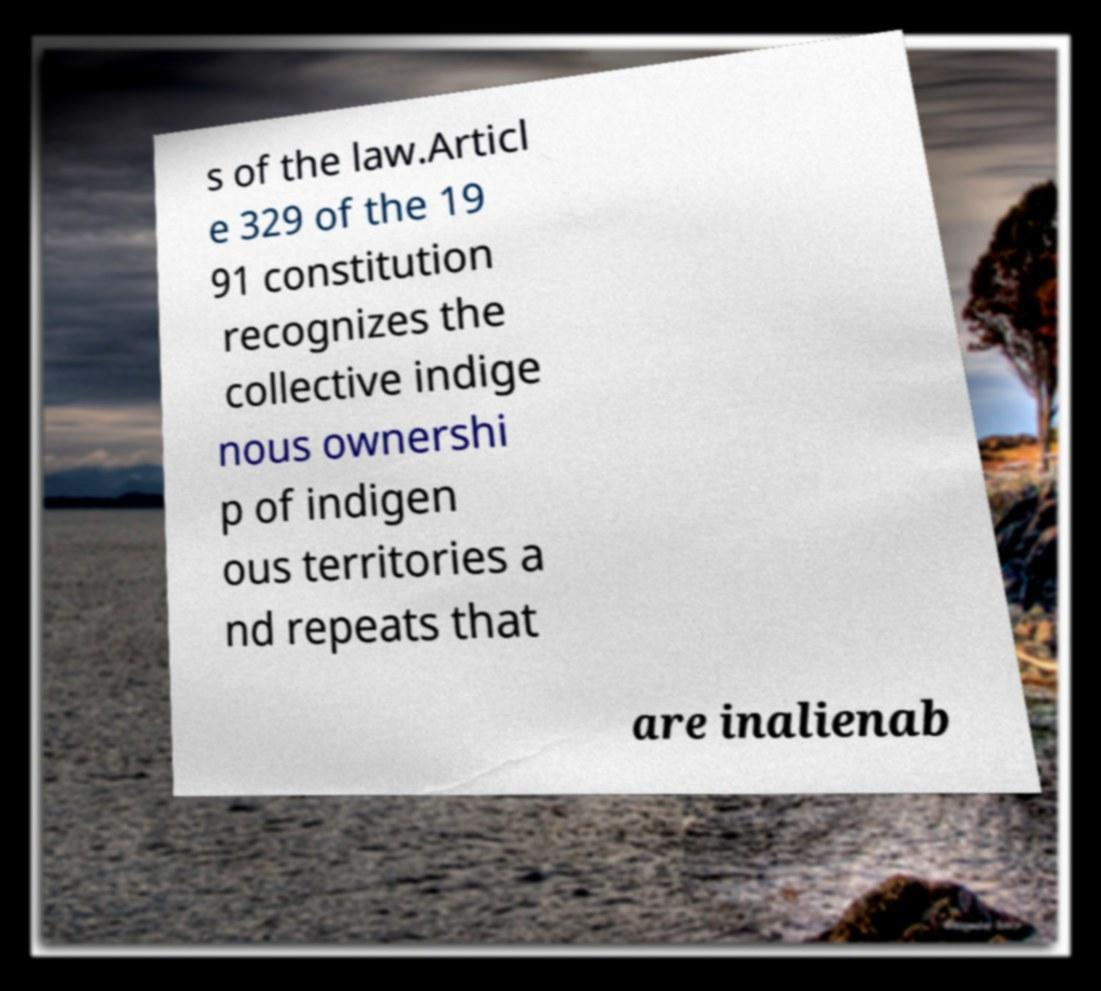Please read and relay the text visible in this image. What does it say? s of the law.Articl e 329 of the 19 91 constitution recognizes the collective indige nous ownershi p of indigen ous territories a nd repeats that are inalienab 